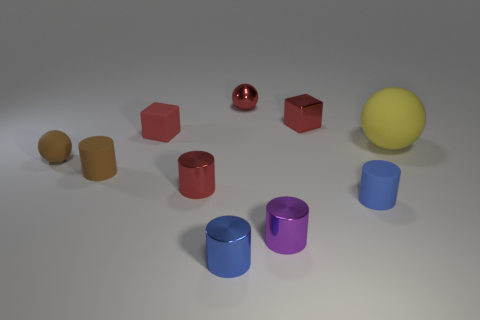Subtract all small balls. How many balls are left? 1 Subtract all cyan blocks. How many blue cylinders are left? 2 Subtract all brown cylinders. How many cylinders are left? 4 Subtract all balls. How many objects are left? 7 Subtract all blue spheres. Subtract all gray cylinders. How many spheres are left? 3 Subtract all yellow things. Subtract all tiny purple shiny things. How many objects are left? 8 Add 5 blue things. How many blue things are left? 7 Add 3 cylinders. How many cylinders exist? 8 Subtract 0 green balls. How many objects are left? 10 